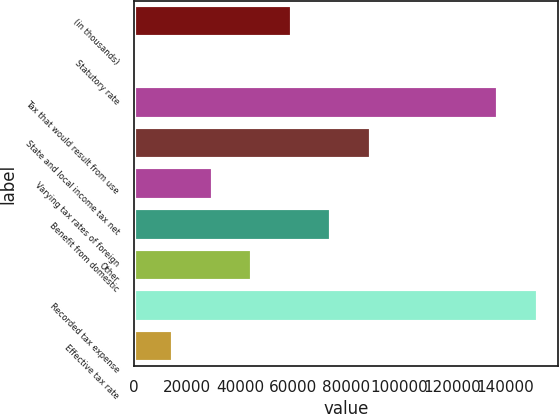Convert chart. <chart><loc_0><loc_0><loc_500><loc_500><bar_chart><fcel>(in thousands)<fcel>Statutory rate<fcel>Tax that would result from use<fcel>State and local income tax net<fcel>Varying tax rates of foreign<fcel>Benefit from domestic<fcel>Other<fcel>Recorded tax expense<fcel>Effective tax rate<nl><fcel>59507<fcel>35<fcel>137283<fcel>89243<fcel>29771<fcel>74375<fcel>44639<fcel>152151<fcel>14903<nl></chart> 